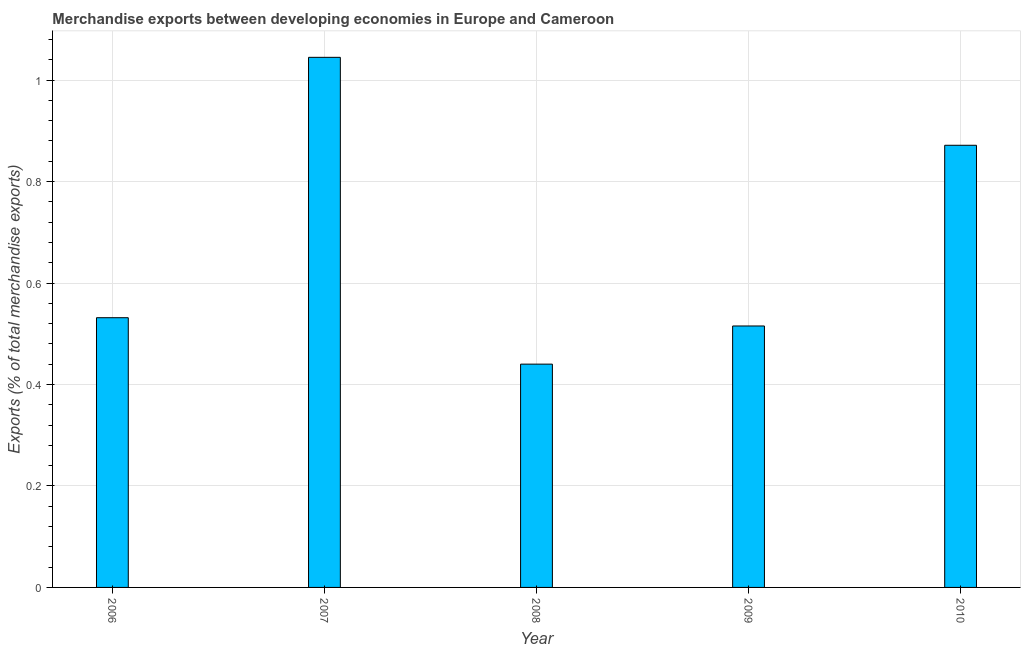Does the graph contain any zero values?
Keep it short and to the point. No. What is the title of the graph?
Your answer should be compact. Merchandise exports between developing economies in Europe and Cameroon. What is the label or title of the Y-axis?
Offer a terse response. Exports (% of total merchandise exports). What is the merchandise exports in 2010?
Your answer should be very brief. 0.87. Across all years, what is the maximum merchandise exports?
Offer a very short reply. 1.04. Across all years, what is the minimum merchandise exports?
Your response must be concise. 0.44. What is the sum of the merchandise exports?
Your answer should be very brief. 3.4. What is the difference between the merchandise exports in 2006 and 2009?
Ensure brevity in your answer.  0.02. What is the average merchandise exports per year?
Make the answer very short. 0.68. What is the median merchandise exports?
Your response must be concise. 0.53. Do a majority of the years between 2008 and 2007 (inclusive) have merchandise exports greater than 0.56 %?
Give a very brief answer. No. What is the ratio of the merchandise exports in 2008 to that in 2010?
Offer a terse response. 0.51. Is the merchandise exports in 2007 less than that in 2008?
Ensure brevity in your answer.  No. What is the difference between the highest and the second highest merchandise exports?
Your answer should be compact. 0.17. What is the difference between the highest and the lowest merchandise exports?
Your answer should be very brief. 0.6. How many bars are there?
Offer a terse response. 5. How many years are there in the graph?
Offer a terse response. 5. What is the Exports (% of total merchandise exports) in 2006?
Keep it short and to the point. 0.53. What is the Exports (% of total merchandise exports) of 2007?
Keep it short and to the point. 1.04. What is the Exports (% of total merchandise exports) in 2008?
Offer a very short reply. 0.44. What is the Exports (% of total merchandise exports) in 2009?
Provide a succinct answer. 0.52. What is the Exports (% of total merchandise exports) of 2010?
Offer a terse response. 0.87. What is the difference between the Exports (% of total merchandise exports) in 2006 and 2007?
Offer a very short reply. -0.51. What is the difference between the Exports (% of total merchandise exports) in 2006 and 2008?
Give a very brief answer. 0.09. What is the difference between the Exports (% of total merchandise exports) in 2006 and 2009?
Make the answer very short. 0.02. What is the difference between the Exports (% of total merchandise exports) in 2006 and 2010?
Your response must be concise. -0.34. What is the difference between the Exports (% of total merchandise exports) in 2007 and 2008?
Give a very brief answer. 0.6. What is the difference between the Exports (% of total merchandise exports) in 2007 and 2009?
Keep it short and to the point. 0.53. What is the difference between the Exports (% of total merchandise exports) in 2007 and 2010?
Provide a succinct answer. 0.17. What is the difference between the Exports (% of total merchandise exports) in 2008 and 2009?
Your response must be concise. -0.08. What is the difference between the Exports (% of total merchandise exports) in 2008 and 2010?
Offer a terse response. -0.43. What is the difference between the Exports (% of total merchandise exports) in 2009 and 2010?
Your answer should be compact. -0.36. What is the ratio of the Exports (% of total merchandise exports) in 2006 to that in 2007?
Provide a short and direct response. 0.51. What is the ratio of the Exports (% of total merchandise exports) in 2006 to that in 2008?
Your response must be concise. 1.21. What is the ratio of the Exports (% of total merchandise exports) in 2006 to that in 2009?
Provide a short and direct response. 1.03. What is the ratio of the Exports (% of total merchandise exports) in 2006 to that in 2010?
Offer a very short reply. 0.61. What is the ratio of the Exports (% of total merchandise exports) in 2007 to that in 2008?
Keep it short and to the point. 2.37. What is the ratio of the Exports (% of total merchandise exports) in 2007 to that in 2009?
Make the answer very short. 2.03. What is the ratio of the Exports (% of total merchandise exports) in 2007 to that in 2010?
Provide a succinct answer. 1.2. What is the ratio of the Exports (% of total merchandise exports) in 2008 to that in 2009?
Make the answer very short. 0.85. What is the ratio of the Exports (% of total merchandise exports) in 2008 to that in 2010?
Give a very brief answer. 0.51. What is the ratio of the Exports (% of total merchandise exports) in 2009 to that in 2010?
Provide a short and direct response. 0.59. 